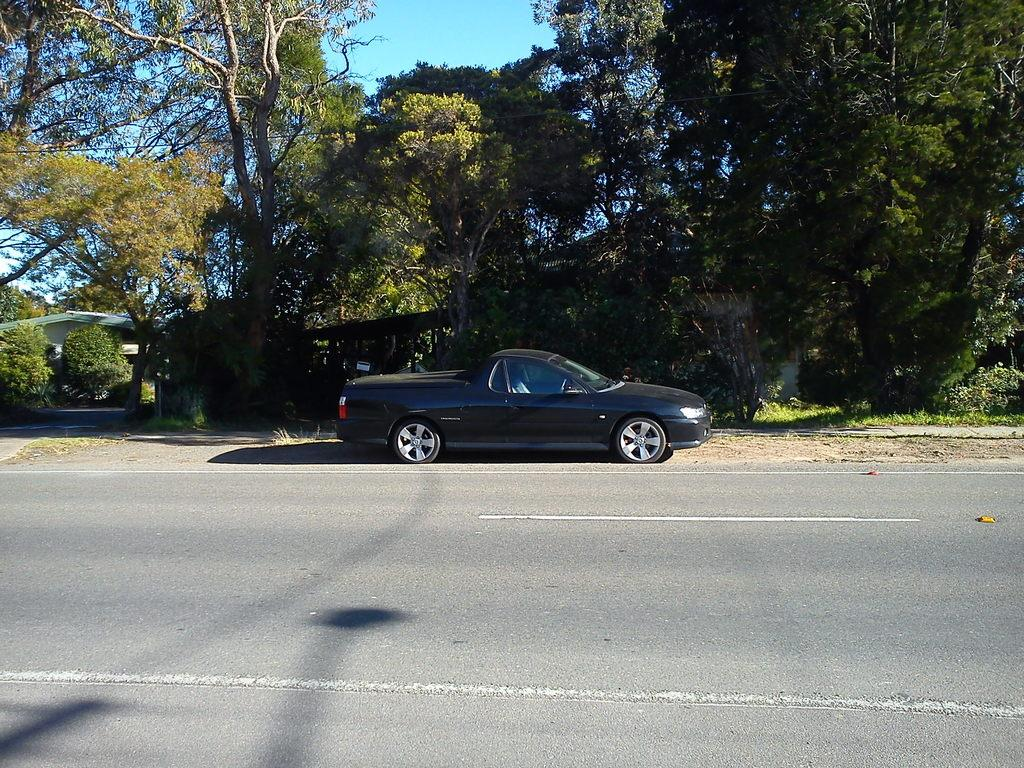What is located at the bottom of the image? There is a road at the bottom of the image. What can be seen behind the road? There is a car behind the road. What is located behind the car? There are trees behind the car. What is situated behind the trees? There are houses behind the trees. What type of organization is responsible for the car's maintenance in the image? There is no information about the car's maintenance or any organization in the image. 